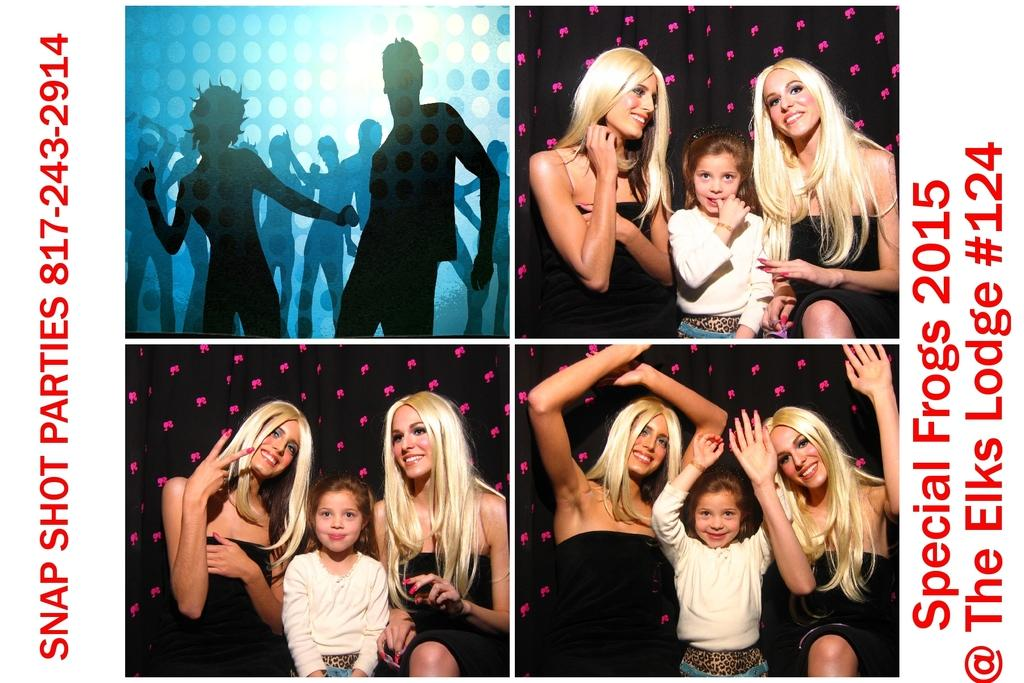Who or what is present in the image? There are people in the image. What is the facial expression of the people in the image? The people have smiles on their faces. Where can text be found in the image? There is text on the left side of the image and on the right side of the image. Can you see any baby birds making a discovery in the image? There are no baby birds or any discovery being made in the image; it features people with smiles on their faces. 